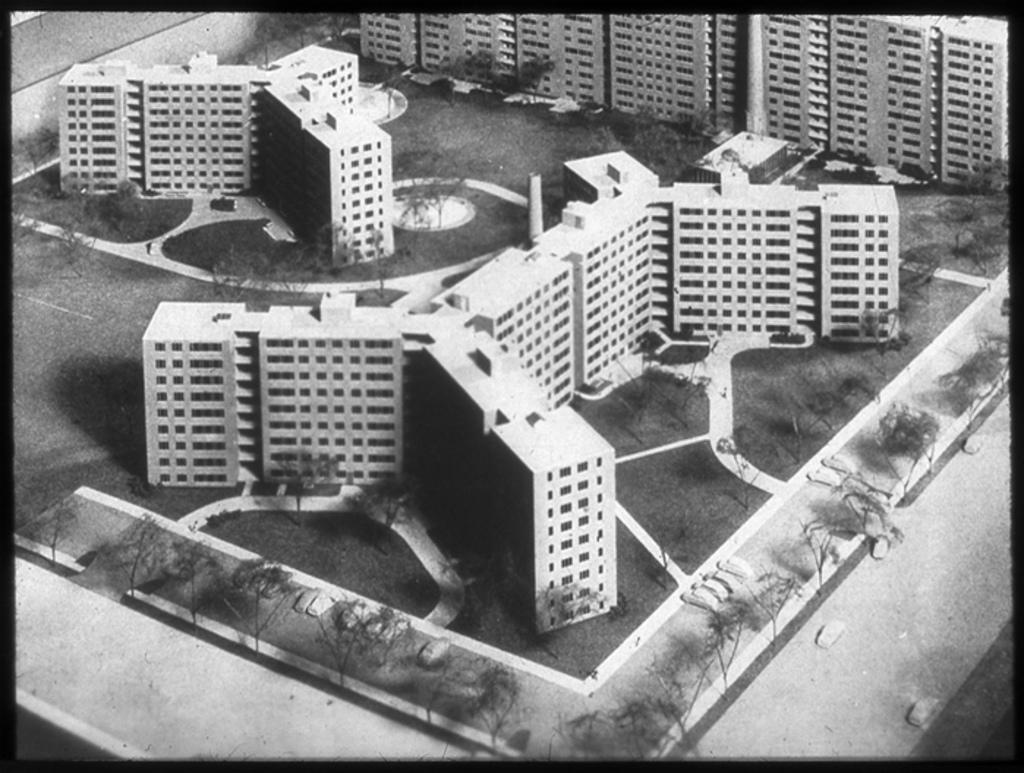What is the color scheme of the image? The image is black and white. What type of structures can be seen in the image? There are buildings in the image. What is covering the ground in the image? Grass is present on the ground. What type of vegetation is visible in the image? There are trees in the image. What is moving along the road in the image? Vehicles are visible on the road. What else can be seen in the image besides the mentioned elements? There are objects in the image. Where is the pump located in the image? There is no pump present in the image. What type of carriage can be seen in the image? There is no carriage present in the image. 